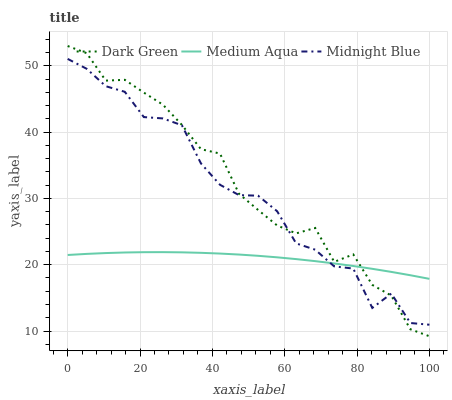Does Midnight Blue have the minimum area under the curve?
Answer yes or no. No. Does Midnight Blue have the maximum area under the curve?
Answer yes or no. No. Is Dark Green the smoothest?
Answer yes or no. No. Is Dark Green the roughest?
Answer yes or no. No. Does Midnight Blue have the lowest value?
Answer yes or no. No. Does Midnight Blue have the highest value?
Answer yes or no. No. 